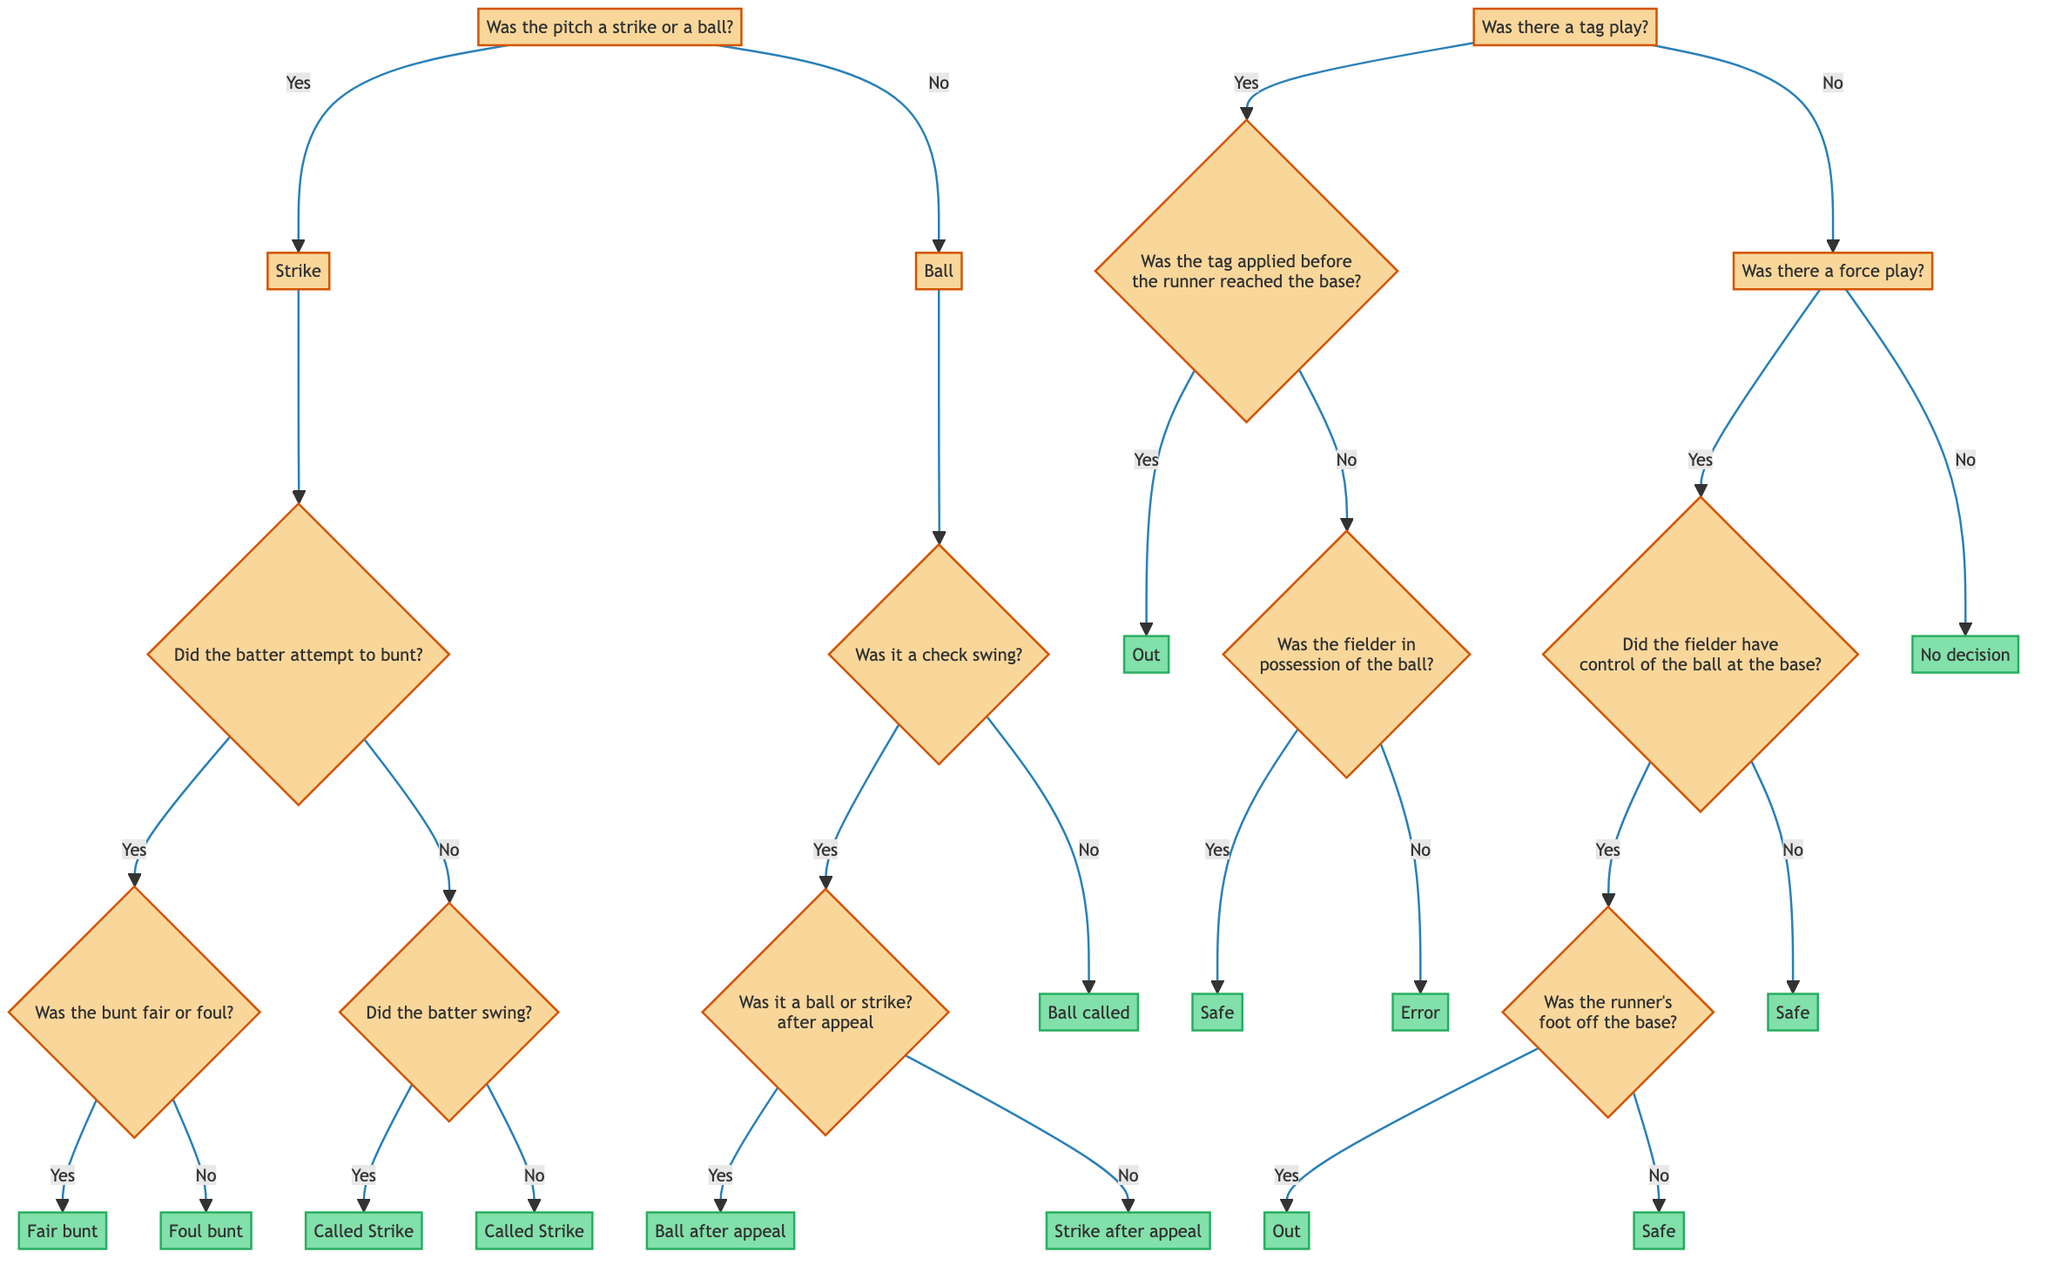What is the first decision node in the diagram? The first decision node is "Was the pitch a strike or a ball?" which serves as the starting point of the decision tree.
Answer: Was the pitch a strike or a ball? How many outcomes are listed after the strike decision? After the decision of "Strike," there are three potential outcomes: "Fair bunt," "Foul bunt," and "Called Strike". This includes different branches based on whether the batter attempted to bunt or swung.
Answer: Three What happens if the pitch is called a ball and there is no check swing? If the pitch is called a ball and there is no check swing, the outcome is "Ball called". Therefore, this is a straightforward outcome based on the decision node.
Answer: Ball called If there is a tag play and the tag was not applied before the runner reached the base, what other consideration is taken next? If the tag was not applied before the runner reached the base, the next consideration is whether the fielder was in possession of the ball. This decision leads to two potential outcomes: "Safe" or "Error".
Answer: Was the fielder in possession of the ball? In the force play section, what outcome occurs if the fielder did not have control of the ball at the base? If the fielder did not have control of the ball during the force play, the outcome is "Safe". This decision follows from the previous checks in the flow of the diagram.
Answer: Safe What is the final decision if the runner's foot is off the base during a force play? If the runner's foot is off the base during a force play, the final decision is "Out". This conclusion is reached after confirming the fielder had control over the ball at the base.
Answer: Out 